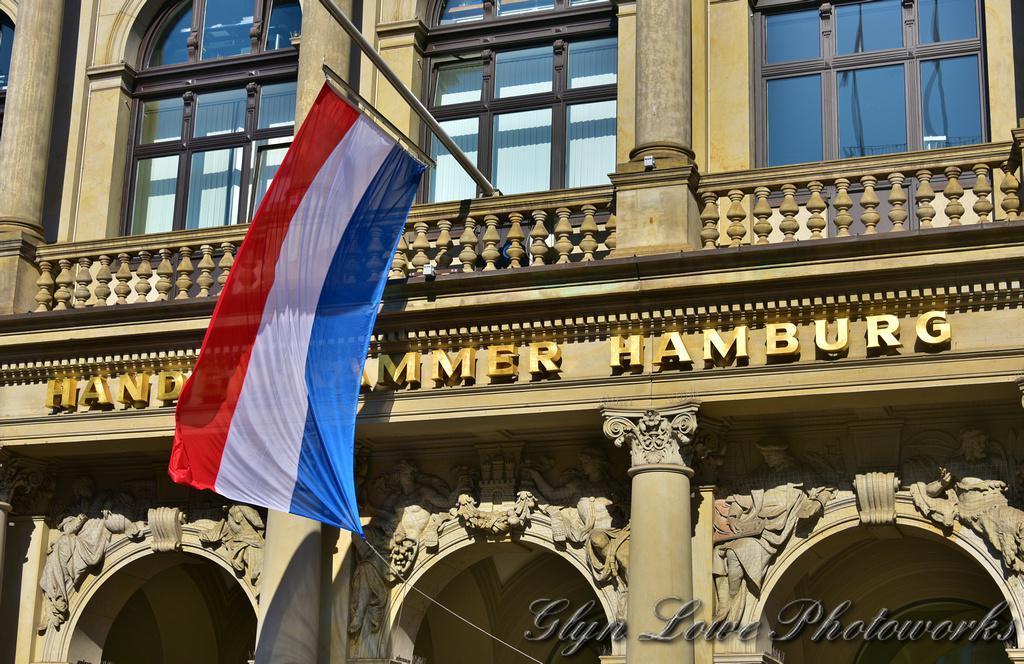Please provide a concise description of this image. In the image we can see there is a building and there are windows on the building. There is a flag kept on the building and its written ¨HAMBURG¨ on the building. 